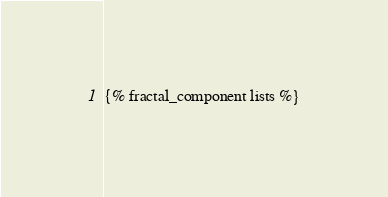Convert code to text. <code><loc_0><loc_0><loc_500><loc_500><_HTML_>{% fractal_component lists %}
</code> 